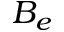Convert formula to latex. <formula><loc_0><loc_0><loc_500><loc_500>B _ { e }</formula> 